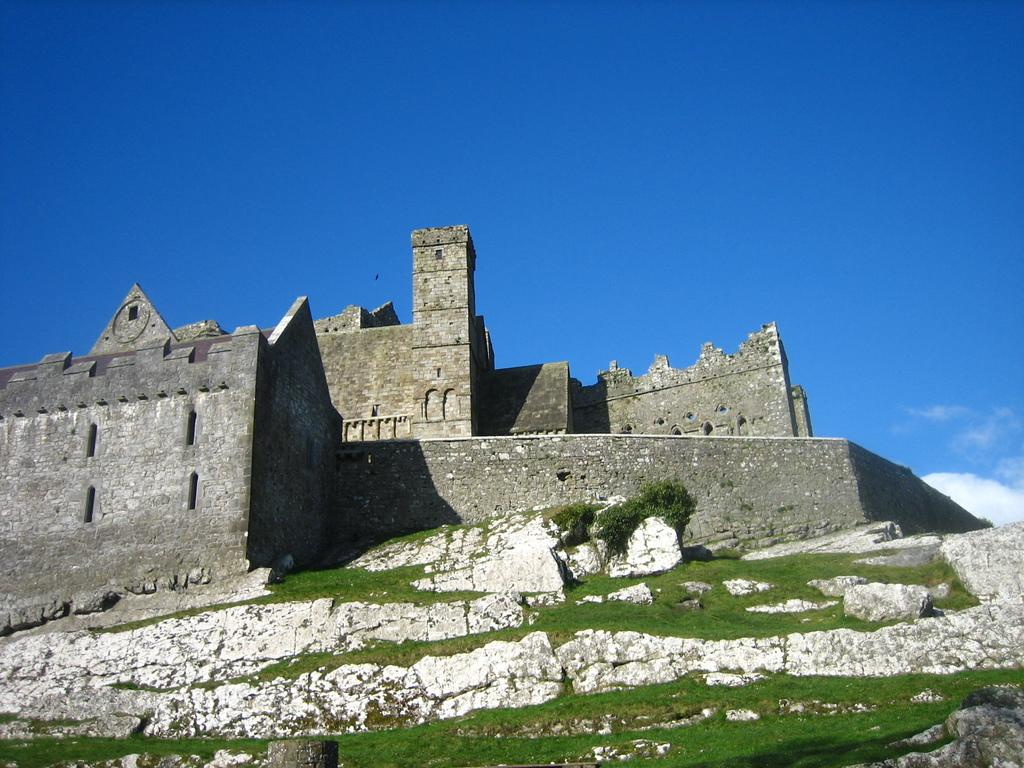What is the main subject of the image? There is a monument in the image. What type of vegetation is present on the land in the image? There is grass on the land in the image. What can be seen in the background of the image? The sky is visible in the background of the image. What type of haircut does the monument have in the image? The monument does not have a haircut, as it is an inanimate object. Is there any writing visible on the monument in the image? The provided facts do not mention any writing on the monument, so we cannot determine if there is any writing visible. 